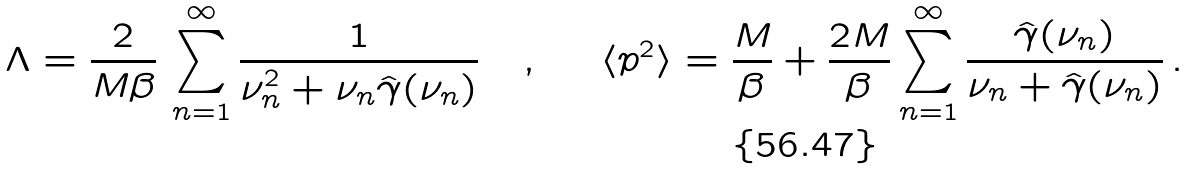<formula> <loc_0><loc_0><loc_500><loc_500>\Lambda = \frac { 2 } { M \beta } \, \sum _ { n = 1 } ^ { \infty } \frac { 1 } { \nu _ { n } ^ { 2 } + \nu _ { n } \hat { \gamma } ( \nu _ { n } ) } \quad , \quad \ \langle p ^ { 2 } \rangle = \frac { M } { \beta } + \frac { 2 M } { \beta } \sum _ { n = 1 } ^ { \infty } \frac { \hat { \gamma } ( \nu _ { n } ) } { \nu _ { n } + \hat { \gamma } ( \nu _ { n } ) } \, .</formula> 